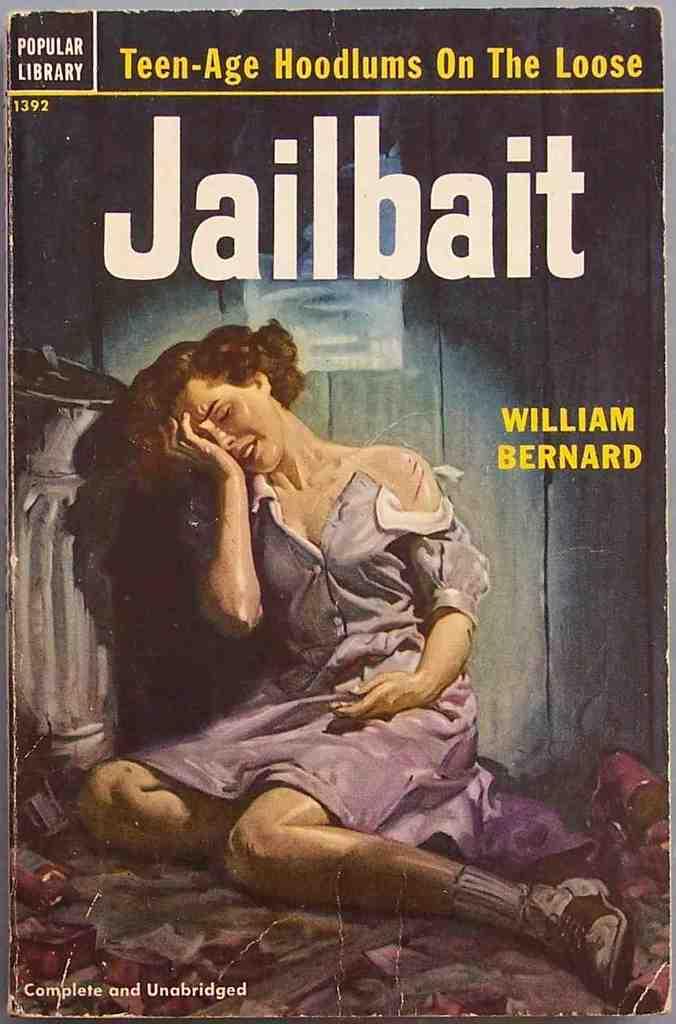What is the book about?
Make the answer very short. Teen-age hoodlums on the loose. Who wrote this?
Provide a succinct answer. William bernard. 